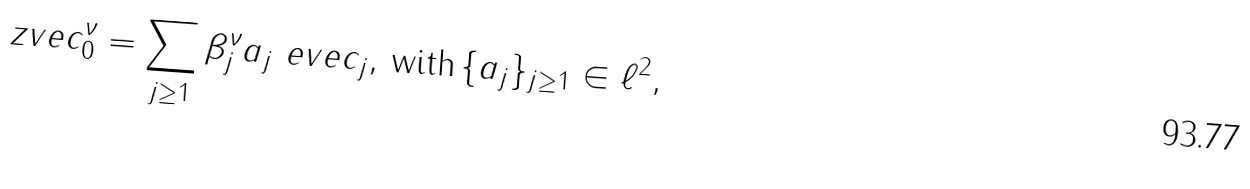<formula> <loc_0><loc_0><loc_500><loc_500>\ z v e c ^ { \nu } _ { 0 } = \sum _ { j \geq 1 } \beta _ { j } ^ { \nu } a _ { j } \ e v e c _ { j } , \, \text {with} \, \{ a _ { j } \} _ { j \geq 1 } \in \ell ^ { 2 } ,</formula> 